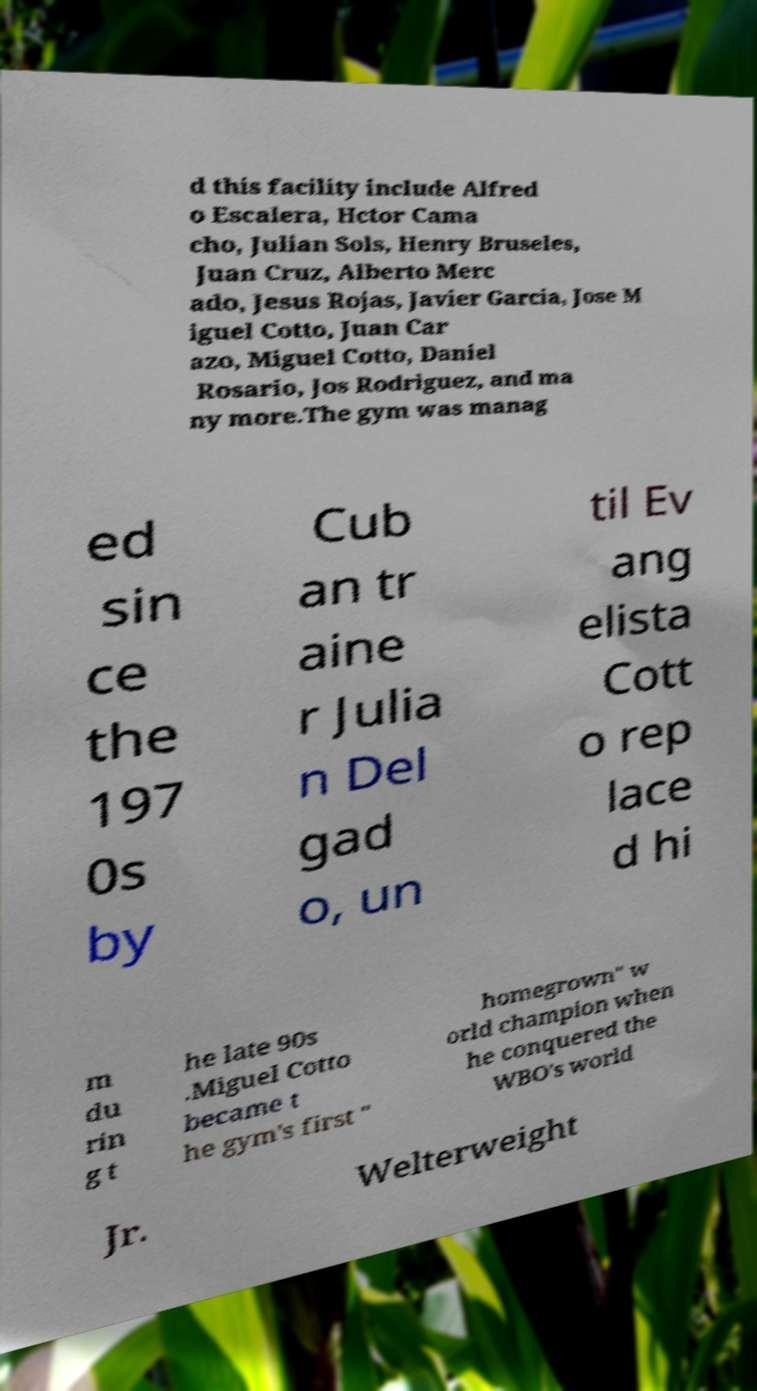Please read and relay the text visible in this image. What does it say? d this facility include Alfred o Escalera, Hctor Cama cho, Julian Sols, Henry Bruseles, Juan Cruz, Alberto Merc ado, Jesus Rojas, Javier Garcia, Jose M iguel Cotto, Juan Car azo, Miguel Cotto, Daniel Rosario, Jos Rodriguez, and ma ny more.The gym was manag ed sin ce the 197 0s by Cub an tr aine r Julia n Del gad o, un til Ev ang elista Cott o rep lace d hi m du rin g t he late 90s .Miguel Cotto became t he gym's first " homegrown" w orld champion when he conquered the WBO's world Jr. Welterweight 